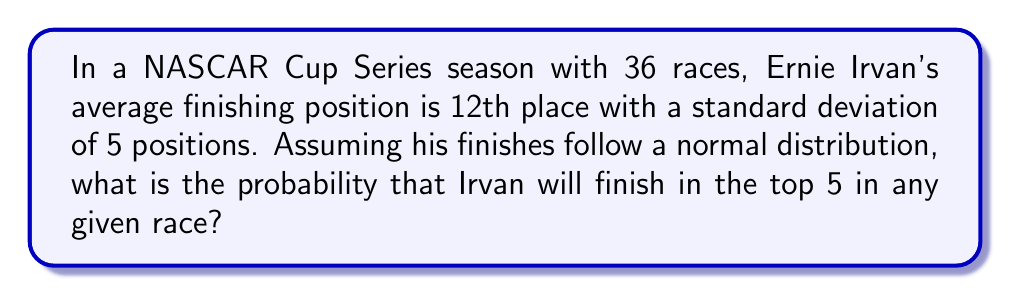Could you help me with this problem? Let's approach this step-by-step:

1) We're dealing with a normal distribution where:
   Mean (μ) = 12
   Standard deviation (σ) = 5

2) We want to find the probability of finishing 5th or better. In statistical terms, we need to find P(X ≤ 5), where X is the finishing position.

3) To use the standard normal distribution table, we need to convert this to a z-score:

   $$z = \frac{X - μ}{σ} = \frac{5 - 12}{5} = -1.4$$

4) We're looking for the area to the left of z = -1.4 on the standard normal distribution.

5) Using a standard normal distribution table or calculator, we find:

   P(Z ≤ -1.4) ≈ 0.0808

6) Therefore, the probability of Ernie Irvan finishing in the top 5 in any given race is approximately 0.0808 or 8.08%.
Answer: 0.0808 